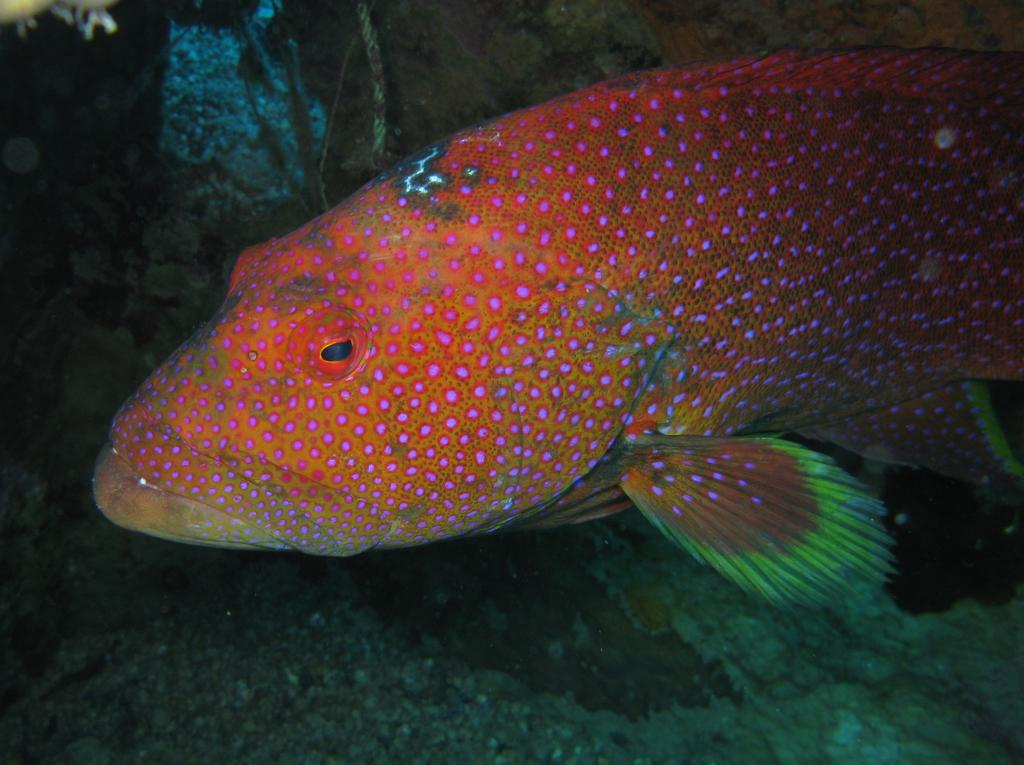What type of animal is in the image? There is a fish in the image. What is the environment in which the fish is located? The fish is in the water in the image. Can you describe any other objects or elements in the water? There are objects in the water in the image. How many giants can be seen interacting with the fish in the image? There are no giants present in the image. What type of ray is visible in the image? There is no ray visible in the image; it only features a fish and objects in the water. 